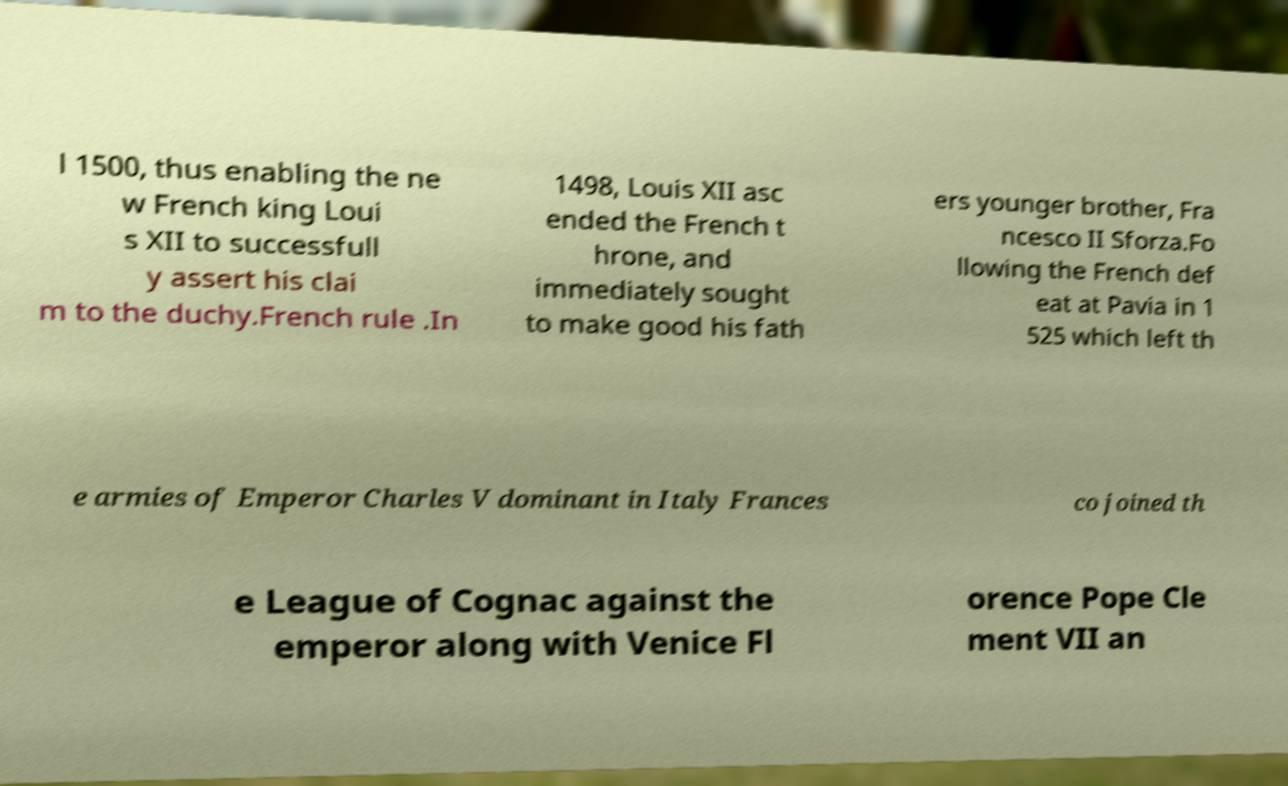Could you assist in decoding the text presented in this image and type it out clearly? l 1500, thus enabling the ne w French king Loui s XII to successfull y assert his clai m to the duchy.French rule .In 1498, Louis XII asc ended the French t hrone, and immediately sought to make good his fath ers younger brother, Fra ncesco II Sforza.Fo llowing the French def eat at Pavia in 1 525 which left th e armies of Emperor Charles V dominant in Italy Frances co joined th e League of Cognac against the emperor along with Venice Fl orence Pope Cle ment VII an 